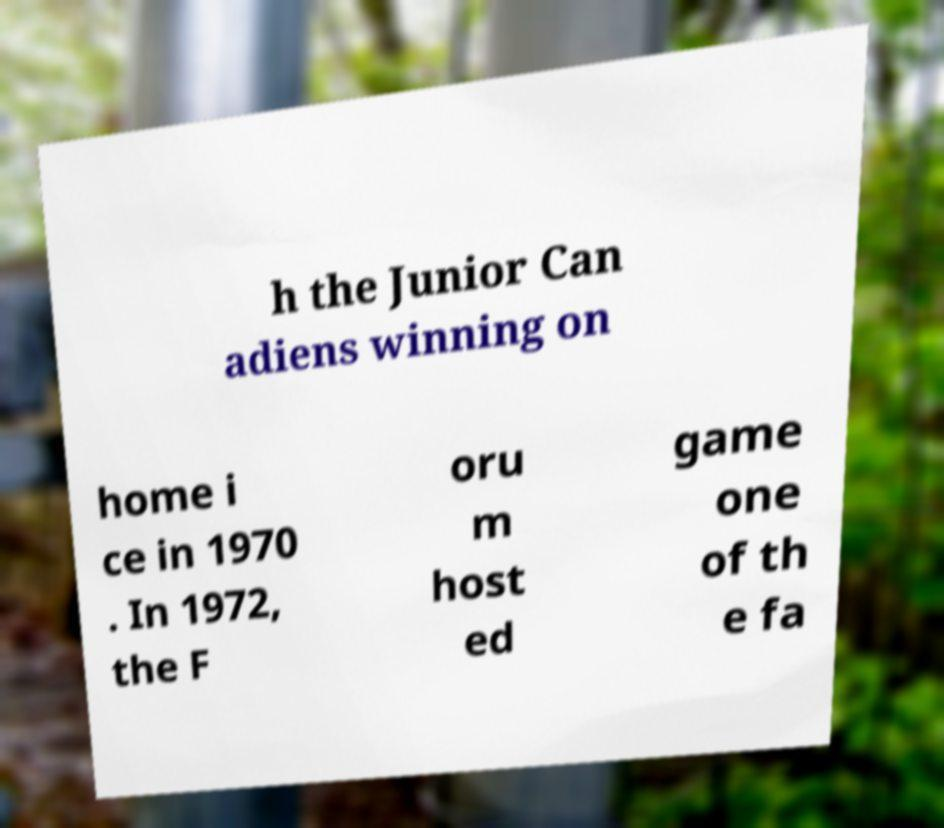Please identify and transcribe the text found in this image. h the Junior Can adiens winning on home i ce in 1970 . In 1972, the F oru m host ed game one of th e fa 